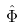Convert formula to latex. <formula><loc_0><loc_0><loc_500><loc_500>\hat { \Phi }</formula> 